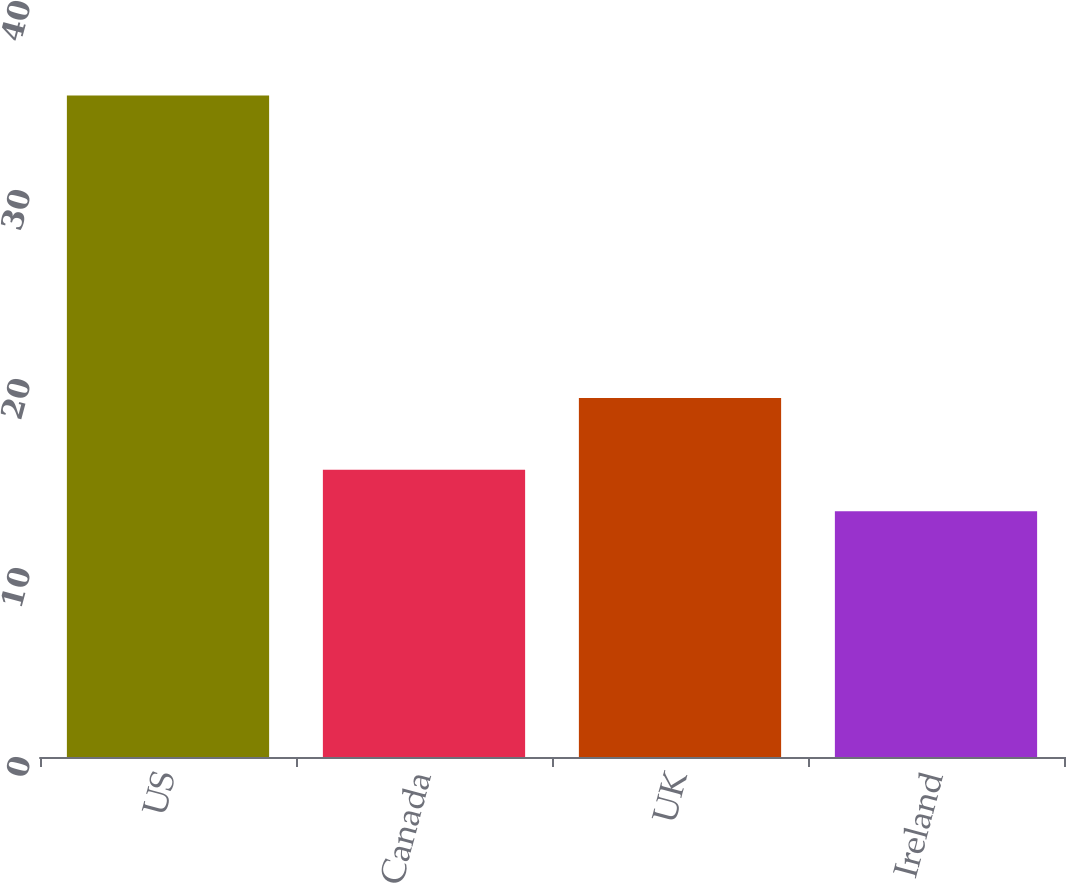<chart> <loc_0><loc_0><loc_500><loc_500><bar_chart><fcel>US<fcel>Canada<fcel>UK<fcel>Ireland<nl><fcel>35<fcel>15.2<fcel>19<fcel>13<nl></chart> 